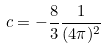<formula> <loc_0><loc_0><loc_500><loc_500>c = - \frac { 8 } { 3 } \frac { 1 } { ( 4 \pi ) ^ { 2 } }</formula> 